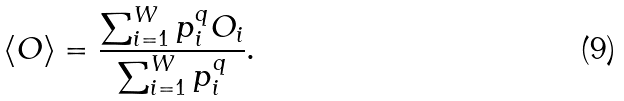Convert formula to latex. <formula><loc_0><loc_0><loc_500><loc_500>\langle O \rangle = \frac { \sum _ { i = 1 } ^ { W } p _ { i } ^ { q } O _ { i } } { \sum _ { i = 1 } ^ { W } p _ { i } ^ { q } } .</formula> 